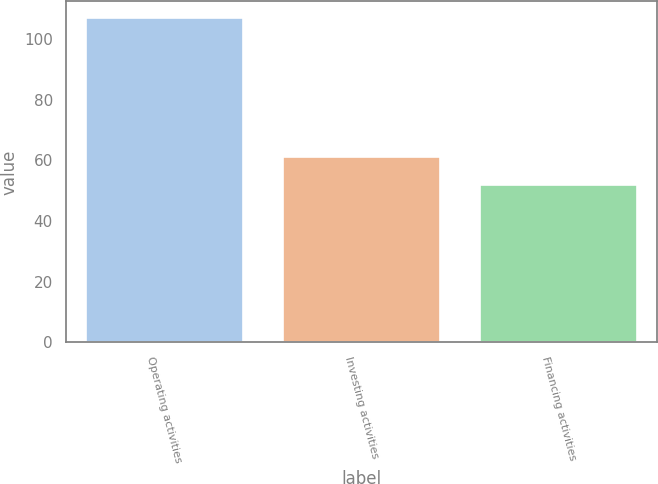<chart> <loc_0><loc_0><loc_500><loc_500><bar_chart><fcel>Operating activities<fcel>Investing activities<fcel>Financing activities<nl><fcel>107<fcel>61<fcel>52<nl></chart> 